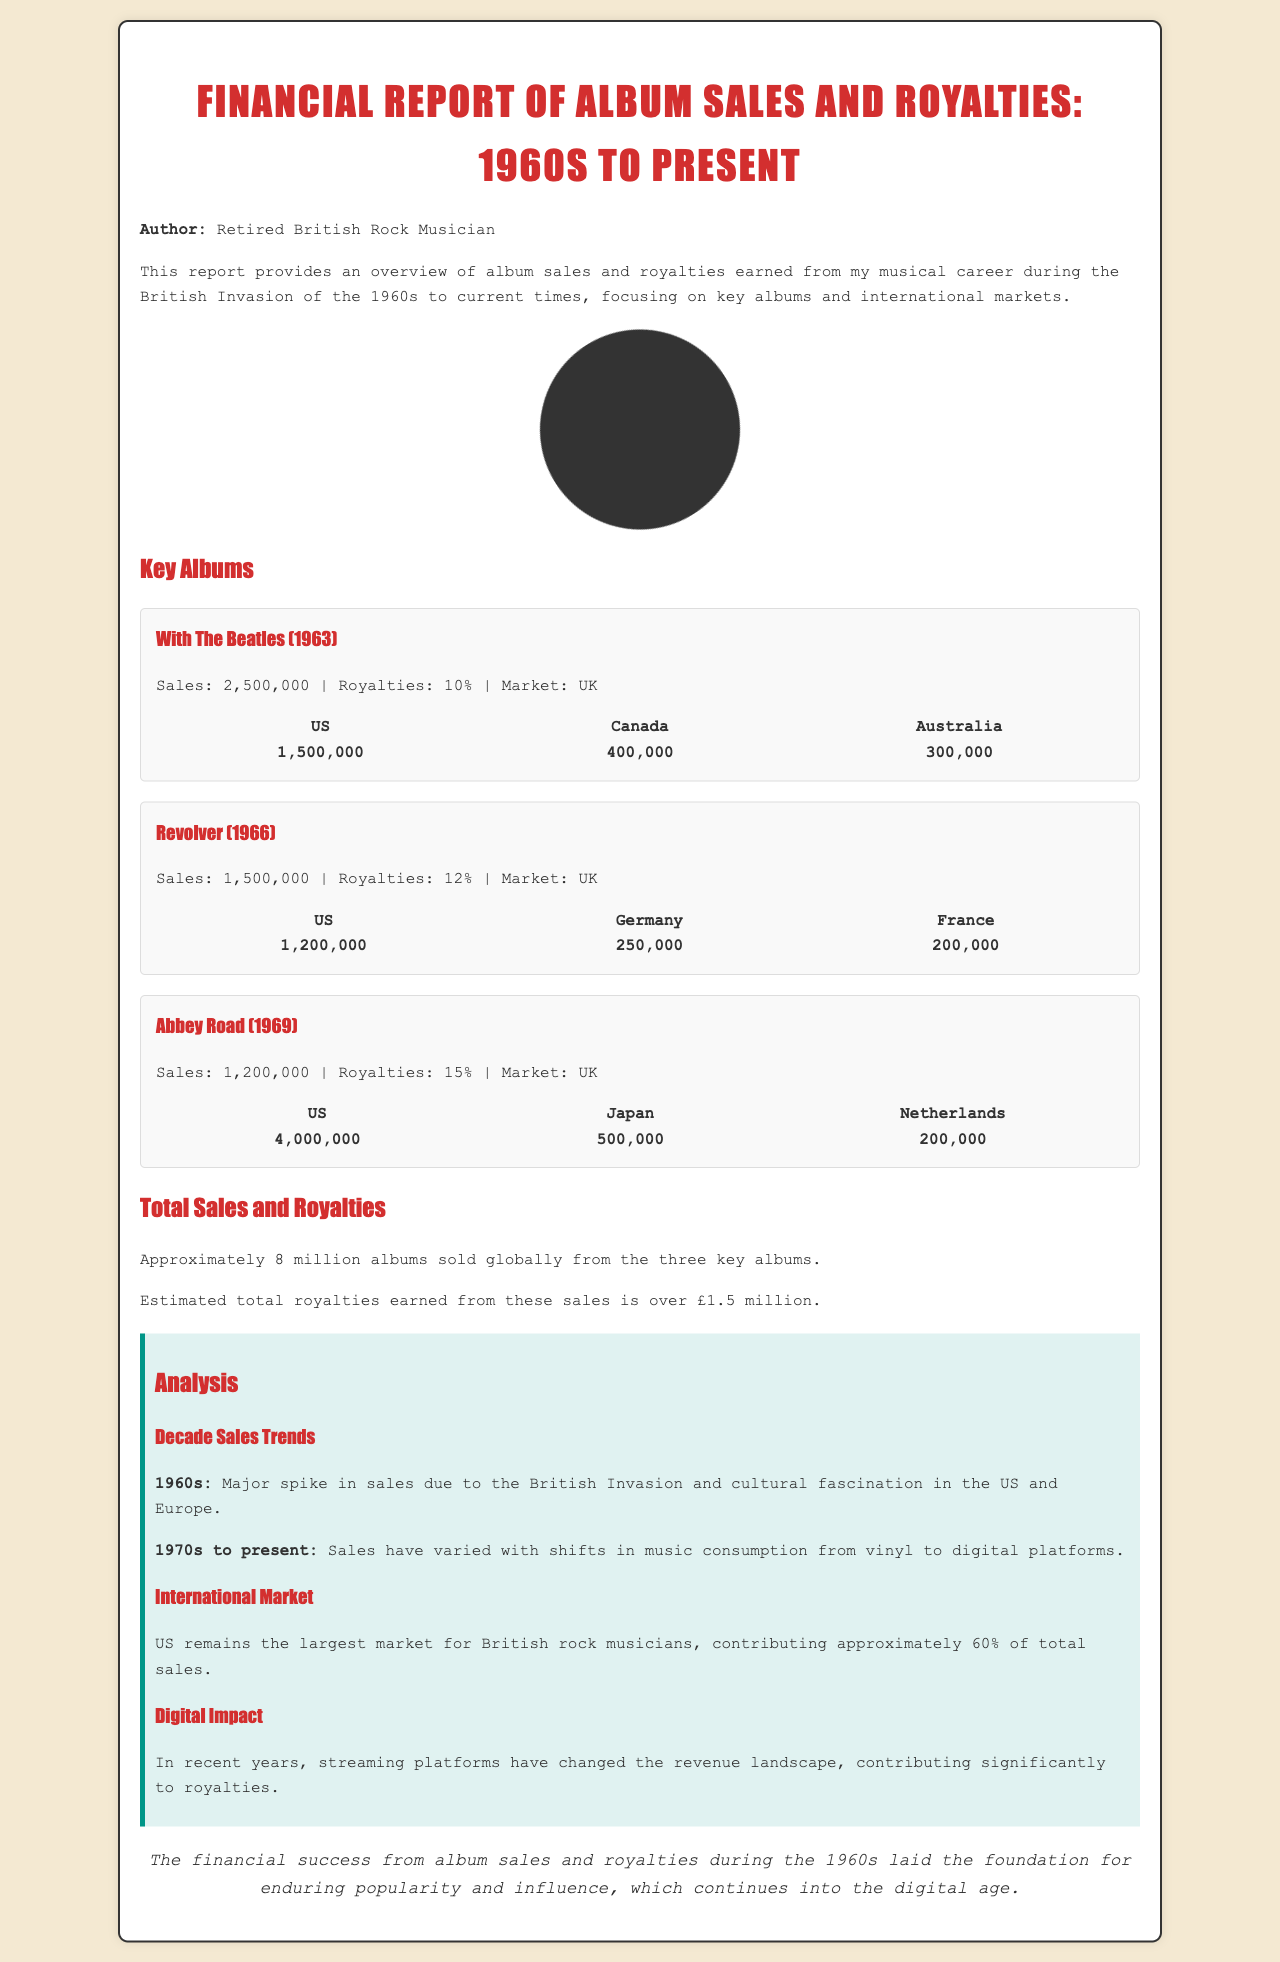What is the total sales from "With The Beatles"? The sales figure for "With The Beatles" is listed in the document as 2,500,000.
Answer: 2,500,000 How many albums sold globally from the three key albums? The document states that approximately 8 million albums were sold globally from the key albums mentioned.
Answer: 8 million What percentage royalties were earned from "Revolver"? The royalty percentage for "Revolver" listed in the document is 12%.
Answer: 12% Which country is the largest market for British rock musicians? The document indicates that the US is the largest market for British rock musicians.
Answer: US What year was "Abbey Road" released? The release year for "Abbey Road" is mentioned in the document as 1969.
Answer: 1969 How many albums were sold in Japan from "Abbey Road"? The document details that 500,000 albums were sold in Japan from "Abbey Road."
Answer: 500,000 What major trend occurred in the 1960s regarding sales? The 1960s experienced a major spike in sales due to the British Invasion and cultural fascination.
Answer: Major spike What is the estimated total royalties earned from the three key albums? The document estimates the total royalties earned from these sales to be over £1.5 million.
Answer: Over £1.5 million What has changed in the revenue landscape in recent years? The document states that streaming platforms have changed the revenue landscape significantly.
Answer: Streaming platforms 